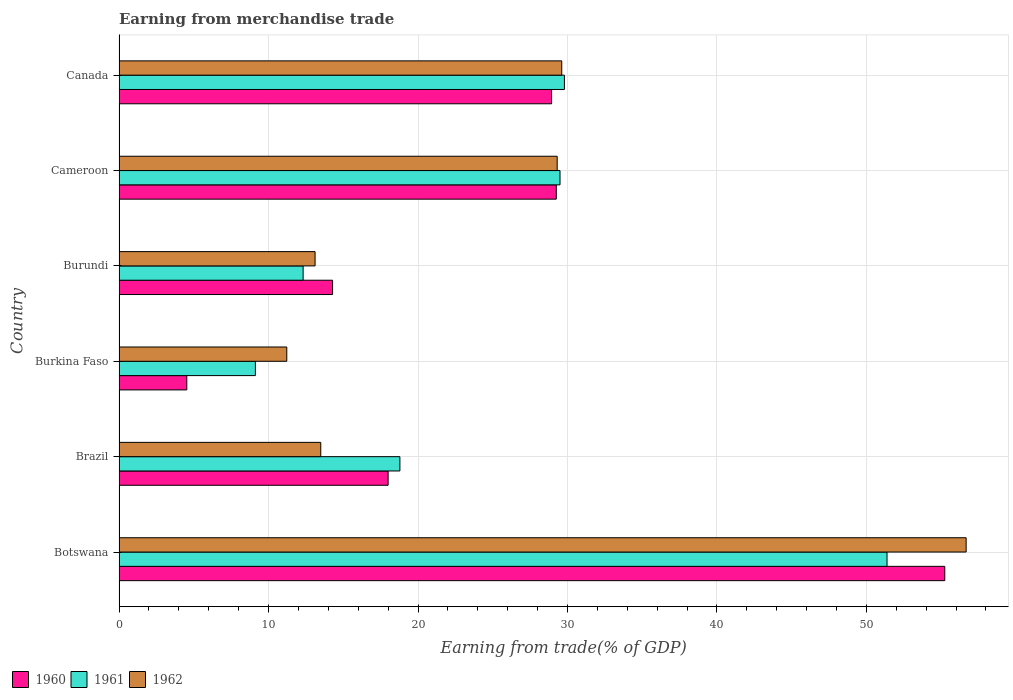What is the label of the 1st group of bars from the top?
Your answer should be very brief. Canada. What is the earnings from trade in 1960 in Canada?
Keep it short and to the point. 28.94. Across all countries, what is the maximum earnings from trade in 1960?
Offer a very short reply. 55.24. Across all countries, what is the minimum earnings from trade in 1960?
Your answer should be very brief. 4.53. In which country was the earnings from trade in 1960 maximum?
Your answer should be very brief. Botswana. In which country was the earnings from trade in 1962 minimum?
Keep it short and to the point. Burkina Faso. What is the total earnings from trade in 1960 in the graph?
Your answer should be very brief. 150.25. What is the difference between the earnings from trade in 1960 in Burundi and that in Canada?
Your answer should be compact. -14.65. What is the difference between the earnings from trade in 1962 in Burundi and the earnings from trade in 1960 in Brazil?
Provide a succinct answer. -4.89. What is the average earnings from trade in 1961 per country?
Provide a succinct answer. 25.15. What is the difference between the earnings from trade in 1961 and earnings from trade in 1960 in Burkina Faso?
Make the answer very short. 4.59. In how many countries, is the earnings from trade in 1962 greater than 40 %?
Your answer should be very brief. 1. What is the ratio of the earnings from trade in 1960 in Burundi to that in Cameroon?
Your response must be concise. 0.49. Is the earnings from trade in 1962 in Brazil less than that in Burkina Faso?
Make the answer very short. No. What is the difference between the highest and the second highest earnings from trade in 1961?
Your response must be concise. 21.58. What is the difference between the highest and the lowest earnings from trade in 1961?
Your answer should be very brief. 42.26. How many bars are there?
Ensure brevity in your answer.  18. Are all the bars in the graph horizontal?
Your response must be concise. Yes. What is the difference between two consecutive major ticks on the X-axis?
Provide a succinct answer. 10. Are the values on the major ticks of X-axis written in scientific E-notation?
Offer a terse response. No. What is the title of the graph?
Provide a short and direct response. Earning from merchandise trade. Does "1966" appear as one of the legend labels in the graph?
Make the answer very short. No. What is the label or title of the X-axis?
Keep it short and to the point. Earning from trade(% of GDP). What is the label or title of the Y-axis?
Offer a terse response. Country. What is the Earning from trade(% of GDP) of 1960 in Botswana?
Provide a succinct answer. 55.24. What is the Earning from trade(% of GDP) in 1961 in Botswana?
Provide a succinct answer. 51.38. What is the Earning from trade(% of GDP) in 1962 in Botswana?
Ensure brevity in your answer.  56.67. What is the Earning from trade(% of GDP) of 1960 in Brazil?
Your answer should be compact. 18. What is the Earning from trade(% of GDP) in 1961 in Brazil?
Offer a terse response. 18.79. What is the Earning from trade(% of GDP) in 1962 in Brazil?
Ensure brevity in your answer.  13.49. What is the Earning from trade(% of GDP) of 1960 in Burkina Faso?
Your response must be concise. 4.53. What is the Earning from trade(% of GDP) in 1961 in Burkina Faso?
Keep it short and to the point. 9.12. What is the Earning from trade(% of GDP) of 1962 in Burkina Faso?
Your response must be concise. 11.22. What is the Earning from trade(% of GDP) of 1960 in Burundi?
Make the answer very short. 14.29. What is the Earning from trade(% of GDP) of 1961 in Burundi?
Provide a short and direct response. 12.32. What is the Earning from trade(% of GDP) of 1962 in Burundi?
Offer a very short reply. 13.11. What is the Earning from trade(% of GDP) of 1960 in Cameroon?
Keep it short and to the point. 29.25. What is the Earning from trade(% of GDP) in 1961 in Cameroon?
Keep it short and to the point. 29.5. What is the Earning from trade(% of GDP) of 1962 in Cameroon?
Your answer should be compact. 29.31. What is the Earning from trade(% of GDP) of 1960 in Canada?
Provide a succinct answer. 28.94. What is the Earning from trade(% of GDP) of 1961 in Canada?
Give a very brief answer. 29.8. What is the Earning from trade(% of GDP) in 1962 in Canada?
Your answer should be compact. 29.62. Across all countries, what is the maximum Earning from trade(% of GDP) of 1960?
Offer a very short reply. 55.24. Across all countries, what is the maximum Earning from trade(% of GDP) of 1961?
Your answer should be very brief. 51.38. Across all countries, what is the maximum Earning from trade(% of GDP) in 1962?
Ensure brevity in your answer.  56.67. Across all countries, what is the minimum Earning from trade(% of GDP) of 1960?
Provide a short and direct response. 4.53. Across all countries, what is the minimum Earning from trade(% of GDP) of 1961?
Provide a succinct answer. 9.12. Across all countries, what is the minimum Earning from trade(% of GDP) of 1962?
Keep it short and to the point. 11.22. What is the total Earning from trade(% of GDP) of 1960 in the graph?
Provide a short and direct response. 150.25. What is the total Earning from trade(% of GDP) in 1961 in the graph?
Ensure brevity in your answer.  150.9. What is the total Earning from trade(% of GDP) of 1962 in the graph?
Offer a terse response. 153.43. What is the difference between the Earning from trade(% of GDP) in 1960 in Botswana and that in Brazil?
Provide a succinct answer. 37.24. What is the difference between the Earning from trade(% of GDP) of 1961 in Botswana and that in Brazil?
Keep it short and to the point. 32.59. What is the difference between the Earning from trade(% of GDP) of 1962 in Botswana and that in Brazil?
Ensure brevity in your answer.  43.18. What is the difference between the Earning from trade(% of GDP) in 1960 in Botswana and that in Burkina Faso?
Offer a terse response. 50.71. What is the difference between the Earning from trade(% of GDP) in 1961 in Botswana and that in Burkina Faso?
Make the answer very short. 42.26. What is the difference between the Earning from trade(% of GDP) of 1962 in Botswana and that in Burkina Faso?
Provide a short and direct response. 45.45. What is the difference between the Earning from trade(% of GDP) in 1960 in Botswana and that in Burundi?
Give a very brief answer. 40.96. What is the difference between the Earning from trade(% of GDP) of 1961 in Botswana and that in Burundi?
Your response must be concise. 39.06. What is the difference between the Earning from trade(% of GDP) of 1962 in Botswana and that in Burundi?
Offer a terse response. 43.56. What is the difference between the Earning from trade(% of GDP) of 1960 in Botswana and that in Cameroon?
Give a very brief answer. 25.99. What is the difference between the Earning from trade(% of GDP) in 1961 in Botswana and that in Cameroon?
Your answer should be very brief. 21.88. What is the difference between the Earning from trade(% of GDP) in 1962 in Botswana and that in Cameroon?
Your answer should be compact. 27.36. What is the difference between the Earning from trade(% of GDP) of 1960 in Botswana and that in Canada?
Provide a succinct answer. 26.3. What is the difference between the Earning from trade(% of GDP) of 1961 in Botswana and that in Canada?
Provide a succinct answer. 21.58. What is the difference between the Earning from trade(% of GDP) in 1962 in Botswana and that in Canada?
Keep it short and to the point. 27.05. What is the difference between the Earning from trade(% of GDP) in 1960 in Brazil and that in Burkina Faso?
Provide a short and direct response. 13.47. What is the difference between the Earning from trade(% of GDP) of 1961 in Brazil and that in Burkina Faso?
Your answer should be compact. 9.67. What is the difference between the Earning from trade(% of GDP) of 1962 in Brazil and that in Burkina Faso?
Keep it short and to the point. 2.27. What is the difference between the Earning from trade(% of GDP) of 1960 in Brazil and that in Burundi?
Keep it short and to the point. 3.72. What is the difference between the Earning from trade(% of GDP) in 1961 in Brazil and that in Burundi?
Offer a very short reply. 6.47. What is the difference between the Earning from trade(% of GDP) in 1962 in Brazil and that in Burundi?
Your answer should be very brief. 0.38. What is the difference between the Earning from trade(% of GDP) in 1960 in Brazil and that in Cameroon?
Ensure brevity in your answer.  -11.25. What is the difference between the Earning from trade(% of GDP) of 1961 in Brazil and that in Cameroon?
Make the answer very short. -10.71. What is the difference between the Earning from trade(% of GDP) in 1962 in Brazil and that in Cameroon?
Ensure brevity in your answer.  -15.82. What is the difference between the Earning from trade(% of GDP) of 1960 in Brazil and that in Canada?
Your answer should be compact. -10.94. What is the difference between the Earning from trade(% of GDP) in 1961 in Brazil and that in Canada?
Give a very brief answer. -11.01. What is the difference between the Earning from trade(% of GDP) in 1962 in Brazil and that in Canada?
Provide a short and direct response. -16.12. What is the difference between the Earning from trade(% of GDP) in 1960 in Burkina Faso and that in Burundi?
Offer a very short reply. -9.75. What is the difference between the Earning from trade(% of GDP) in 1961 in Burkina Faso and that in Burundi?
Your response must be concise. -3.19. What is the difference between the Earning from trade(% of GDP) of 1962 in Burkina Faso and that in Burundi?
Offer a terse response. -1.89. What is the difference between the Earning from trade(% of GDP) of 1960 in Burkina Faso and that in Cameroon?
Provide a succinct answer. -24.72. What is the difference between the Earning from trade(% of GDP) in 1961 in Burkina Faso and that in Cameroon?
Your answer should be compact. -20.38. What is the difference between the Earning from trade(% of GDP) of 1962 in Burkina Faso and that in Cameroon?
Provide a short and direct response. -18.09. What is the difference between the Earning from trade(% of GDP) in 1960 in Burkina Faso and that in Canada?
Offer a very short reply. -24.41. What is the difference between the Earning from trade(% of GDP) of 1961 in Burkina Faso and that in Canada?
Make the answer very short. -20.68. What is the difference between the Earning from trade(% of GDP) in 1962 in Burkina Faso and that in Canada?
Your response must be concise. -18.4. What is the difference between the Earning from trade(% of GDP) of 1960 in Burundi and that in Cameroon?
Provide a succinct answer. -14.97. What is the difference between the Earning from trade(% of GDP) in 1961 in Burundi and that in Cameroon?
Provide a succinct answer. -17.19. What is the difference between the Earning from trade(% of GDP) of 1962 in Burundi and that in Cameroon?
Your answer should be very brief. -16.2. What is the difference between the Earning from trade(% of GDP) in 1960 in Burundi and that in Canada?
Your response must be concise. -14.65. What is the difference between the Earning from trade(% of GDP) of 1961 in Burundi and that in Canada?
Provide a short and direct response. -17.48. What is the difference between the Earning from trade(% of GDP) of 1962 in Burundi and that in Canada?
Offer a terse response. -16.5. What is the difference between the Earning from trade(% of GDP) in 1960 in Cameroon and that in Canada?
Offer a terse response. 0.32. What is the difference between the Earning from trade(% of GDP) in 1961 in Cameroon and that in Canada?
Keep it short and to the point. -0.3. What is the difference between the Earning from trade(% of GDP) in 1962 in Cameroon and that in Canada?
Offer a terse response. -0.3. What is the difference between the Earning from trade(% of GDP) of 1960 in Botswana and the Earning from trade(% of GDP) of 1961 in Brazil?
Your response must be concise. 36.45. What is the difference between the Earning from trade(% of GDP) of 1960 in Botswana and the Earning from trade(% of GDP) of 1962 in Brazil?
Ensure brevity in your answer.  41.75. What is the difference between the Earning from trade(% of GDP) in 1961 in Botswana and the Earning from trade(% of GDP) in 1962 in Brazil?
Your answer should be very brief. 37.88. What is the difference between the Earning from trade(% of GDP) of 1960 in Botswana and the Earning from trade(% of GDP) of 1961 in Burkina Faso?
Ensure brevity in your answer.  46.12. What is the difference between the Earning from trade(% of GDP) in 1960 in Botswana and the Earning from trade(% of GDP) in 1962 in Burkina Faso?
Keep it short and to the point. 44.02. What is the difference between the Earning from trade(% of GDP) of 1961 in Botswana and the Earning from trade(% of GDP) of 1962 in Burkina Faso?
Provide a short and direct response. 40.16. What is the difference between the Earning from trade(% of GDP) of 1960 in Botswana and the Earning from trade(% of GDP) of 1961 in Burundi?
Offer a very short reply. 42.93. What is the difference between the Earning from trade(% of GDP) in 1960 in Botswana and the Earning from trade(% of GDP) in 1962 in Burundi?
Your response must be concise. 42.13. What is the difference between the Earning from trade(% of GDP) in 1961 in Botswana and the Earning from trade(% of GDP) in 1962 in Burundi?
Provide a succinct answer. 38.26. What is the difference between the Earning from trade(% of GDP) of 1960 in Botswana and the Earning from trade(% of GDP) of 1961 in Cameroon?
Give a very brief answer. 25.74. What is the difference between the Earning from trade(% of GDP) in 1960 in Botswana and the Earning from trade(% of GDP) in 1962 in Cameroon?
Your answer should be compact. 25.93. What is the difference between the Earning from trade(% of GDP) in 1961 in Botswana and the Earning from trade(% of GDP) in 1962 in Cameroon?
Provide a short and direct response. 22.07. What is the difference between the Earning from trade(% of GDP) of 1960 in Botswana and the Earning from trade(% of GDP) of 1961 in Canada?
Provide a succinct answer. 25.45. What is the difference between the Earning from trade(% of GDP) in 1960 in Botswana and the Earning from trade(% of GDP) in 1962 in Canada?
Ensure brevity in your answer.  25.63. What is the difference between the Earning from trade(% of GDP) of 1961 in Botswana and the Earning from trade(% of GDP) of 1962 in Canada?
Offer a very short reply. 21.76. What is the difference between the Earning from trade(% of GDP) of 1960 in Brazil and the Earning from trade(% of GDP) of 1961 in Burkina Faso?
Your answer should be compact. 8.88. What is the difference between the Earning from trade(% of GDP) in 1960 in Brazil and the Earning from trade(% of GDP) in 1962 in Burkina Faso?
Your answer should be compact. 6.78. What is the difference between the Earning from trade(% of GDP) in 1961 in Brazil and the Earning from trade(% of GDP) in 1962 in Burkina Faso?
Provide a succinct answer. 7.57. What is the difference between the Earning from trade(% of GDP) of 1960 in Brazil and the Earning from trade(% of GDP) of 1961 in Burundi?
Provide a short and direct response. 5.69. What is the difference between the Earning from trade(% of GDP) in 1960 in Brazil and the Earning from trade(% of GDP) in 1962 in Burundi?
Your answer should be very brief. 4.89. What is the difference between the Earning from trade(% of GDP) of 1961 in Brazil and the Earning from trade(% of GDP) of 1962 in Burundi?
Your answer should be very brief. 5.68. What is the difference between the Earning from trade(% of GDP) of 1960 in Brazil and the Earning from trade(% of GDP) of 1961 in Cameroon?
Your answer should be very brief. -11.5. What is the difference between the Earning from trade(% of GDP) in 1960 in Brazil and the Earning from trade(% of GDP) in 1962 in Cameroon?
Provide a short and direct response. -11.31. What is the difference between the Earning from trade(% of GDP) in 1961 in Brazil and the Earning from trade(% of GDP) in 1962 in Cameroon?
Offer a terse response. -10.52. What is the difference between the Earning from trade(% of GDP) of 1960 in Brazil and the Earning from trade(% of GDP) of 1961 in Canada?
Ensure brevity in your answer.  -11.8. What is the difference between the Earning from trade(% of GDP) of 1960 in Brazil and the Earning from trade(% of GDP) of 1962 in Canada?
Offer a terse response. -11.62. What is the difference between the Earning from trade(% of GDP) in 1961 in Brazil and the Earning from trade(% of GDP) in 1962 in Canada?
Offer a very short reply. -10.83. What is the difference between the Earning from trade(% of GDP) of 1960 in Burkina Faso and the Earning from trade(% of GDP) of 1961 in Burundi?
Offer a terse response. -7.78. What is the difference between the Earning from trade(% of GDP) in 1960 in Burkina Faso and the Earning from trade(% of GDP) in 1962 in Burundi?
Ensure brevity in your answer.  -8.58. What is the difference between the Earning from trade(% of GDP) of 1961 in Burkina Faso and the Earning from trade(% of GDP) of 1962 in Burundi?
Your answer should be compact. -3.99. What is the difference between the Earning from trade(% of GDP) of 1960 in Burkina Faso and the Earning from trade(% of GDP) of 1961 in Cameroon?
Offer a very short reply. -24.97. What is the difference between the Earning from trade(% of GDP) of 1960 in Burkina Faso and the Earning from trade(% of GDP) of 1962 in Cameroon?
Offer a very short reply. -24.78. What is the difference between the Earning from trade(% of GDP) in 1961 in Burkina Faso and the Earning from trade(% of GDP) in 1962 in Cameroon?
Provide a short and direct response. -20.19. What is the difference between the Earning from trade(% of GDP) in 1960 in Burkina Faso and the Earning from trade(% of GDP) in 1961 in Canada?
Make the answer very short. -25.26. What is the difference between the Earning from trade(% of GDP) in 1960 in Burkina Faso and the Earning from trade(% of GDP) in 1962 in Canada?
Offer a very short reply. -25.08. What is the difference between the Earning from trade(% of GDP) in 1961 in Burkina Faso and the Earning from trade(% of GDP) in 1962 in Canada?
Your answer should be very brief. -20.5. What is the difference between the Earning from trade(% of GDP) of 1960 in Burundi and the Earning from trade(% of GDP) of 1961 in Cameroon?
Offer a very short reply. -15.22. What is the difference between the Earning from trade(% of GDP) of 1960 in Burundi and the Earning from trade(% of GDP) of 1962 in Cameroon?
Provide a short and direct response. -15.03. What is the difference between the Earning from trade(% of GDP) of 1961 in Burundi and the Earning from trade(% of GDP) of 1962 in Cameroon?
Keep it short and to the point. -17. What is the difference between the Earning from trade(% of GDP) of 1960 in Burundi and the Earning from trade(% of GDP) of 1961 in Canada?
Keep it short and to the point. -15.51. What is the difference between the Earning from trade(% of GDP) in 1960 in Burundi and the Earning from trade(% of GDP) in 1962 in Canada?
Your response must be concise. -15.33. What is the difference between the Earning from trade(% of GDP) of 1961 in Burundi and the Earning from trade(% of GDP) of 1962 in Canada?
Your answer should be very brief. -17.3. What is the difference between the Earning from trade(% of GDP) of 1960 in Cameroon and the Earning from trade(% of GDP) of 1961 in Canada?
Offer a very short reply. -0.54. What is the difference between the Earning from trade(% of GDP) of 1960 in Cameroon and the Earning from trade(% of GDP) of 1962 in Canada?
Your response must be concise. -0.36. What is the difference between the Earning from trade(% of GDP) in 1961 in Cameroon and the Earning from trade(% of GDP) in 1962 in Canada?
Your answer should be compact. -0.12. What is the average Earning from trade(% of GDP) of 1960 per country?
Keep it short and to the point. 25.04. What is the average Earning from trade(% of GDP) of 1961 per country?
Your answer should be very brief. 25.15. What is the average Earning from trade(% of GDP) of 1962 per country?
Ensure brevity in your answer.  25.57. What is the difference between the Earning from trade(% of GDP) in 1960 and Earning from trade(% of GDP) in 1961 in Botswana?
Provide a succinct answer. 3.86. What is the difference between the Earning from trade(% of GDP) of 1960 and Earning from trade(% of GDP) of 1962 in Botswana?
Your response must be concise. -1.43. What is the difference between the Earning from trade(% of GDP) in 1961 and Earning from trade(% of GDP) in 1962 in Botswana?
Your answer should be compact. -5.29. What is the difference between the Earning from trade(% of GDP) of 1960 and Earning from trade(% of GDP) of 1961 in Brazil?
Your answer should be very brief. -0.79. What is the difference between the Earning from trade(% of GDP) of 1960 and Earning from trade(% of GDP) of 1962 in Brazil?
Your response must be concise. 4.51. What is the difference between the Earning from trade(% of GDP) in 1961 and Earning from trade(% of GDP) in 1962 in Brazil?
Make the answer very short. 5.3. What is the difference between the Earning from trade(% of GDP) of 1960 and Earning from trade(% of GDP) of 1961 in Burkina Faso?
Keep it short and to the point. -4.59. What is the difference between the Earning from trade(% of GDP) in 1960 and Earning from trade(% of GDP) in 1962 in Burkina Faso?
Your answer should be very brief. -6.69. What is the difference between the Earning from trade(% of GDP) of 1961 and Earning from trade(% of GDP) of 1962 in Burkina Faso?
Provide a short and direct response. -2.1. What is the difference between the Earning from trade(% of GDP) of 1960 and Earning from trade(% of GDP) of 1961 in Burundi?
Provide a succinct answer. 1.97. What is the difference between the Earning from trade(% of GDP) in 1960 and Earning from trade(% of GDP) in 1962 in Burundi?
Make the answer very short. 1.17. What is the difference between the Earning from trade(% of GDP) in 1961 and Earning from trade(% of GDP) in 1962 in Burundi?
Provide a succinct answer. -0.8. What is the difference between the Earning from trade(% of GDP) in 1960 and Earning from trade(% of GDP) in 1961 in Cameroon?
Provide a short and direct response. -0.25. What is the difference between the Earning from trade(% of GDP) in 1960 and Earning from trade(% of GDP) in 1962 in Cameroon?
Make the answer very short. -0.06. What is the difference between the Earning from trade(% of GDP) in 1961 and Earning from trade(% of GDP) in 1962 in Cameroon?
Offer a very short reply. 0.19. What is the difference between the Earning from trade(% of GDP) in 1960 and Earning from trade(% of GDP) in 1961 in Canada?
Ensure brevity in your answer.  -0.86. What is the difference between the Earning from trade(% of GDP) in 1960 and Earning from trade(% of GDP) in 1962 in Canada?
Your answer should be very brief. -0.68. What is the difference between the Earning from trade(% of GDP) of 1961 and Earning from trade(% of GDP) of 1962 in Canada?
Offer a terse response. 0.18. What is the ratio of the Earning from trade(% of GDP) in 1960 in Botswana to that in Brazil?
Provide a short and direct response. 3.07. What is the ratio of the Earning from trade(% of GDP) in 1961 in Botswana to that in Brazil?
Provide a succinct answer. 2.73. What is the ratio of the Earning from trade(% of GDP) of 1962 in Botswana to that in Brazil?
Offer a terse response. 4.2. What is the ratio of the Earning from trade(% of GDP) of 1960 in Botswana to that in Burkina Faso?
Make the answer very short. 12.19. What is the ratio of the Earning from trade(% of GDP) in 1961 in Botswana to that in Burkina Faso?
Make the answer very short. 5.63. What is the ratio of the Earning from trade(% of GDP) of 1962 in Botswana to that in Burkina Faso?
Give a very brief answer. 5.05. What is the ratio of the Earning from trade(% of GDP) of 1960 in Botswana to that in Burundi?
Give a very brief answer. 3.87. What is the ratio of the Earning from trade(% of GDP) in 1961 in Botswana to that in Burundi?
Keep it short and to the point. 4.17. What is the ratio of the Earning from trade(% of GDP) of 1962 in Botswana to that in Burundi?
Offer a very short reply. 4.32. What is the ratio of the Earning from trade(% of GDP) in 1960 in Botswana to that in Cameroon?
Your answer should be compact. 1.89. What is the ratio of the Earning from trade(% of GDP) in 1961 in Botswana to that in Cameroon?
Give a very brief answer. 1.74. What is the ratio of the Earning from trade(% of GDP) of 1962 in Botswana to that in Cameroon?
Your answer should be compact. 1.93. What is the ratio of the Earning from trade(% of GDP) in 1960 in Botswana to that in Canada?
Provide a short and direct response. 1.91. What is the ratio of the Earning from trade(% of GDP) of 1961 in Botswana to that in Canada?
Provide a succinct answer. 1.72. What is the ratio of the Earning from trade(% of GDP) in 1962 in Botswana to that in Canada?
Ensure brevity in your answer.  1.91. What is the ratio of the Earning from trade(% of GDP) of 1960 in Brazil to that in Burkina Faso?
Provide a short and direct response. 3.97. What is the ratio of the Earning from trade(% of GDP) of 1961 in Brazil to that in Burkina Faso?
Give a very brief answer. 2.06. What is the ratio of the Earning from trade(% of GDP) in 1962 in Brazil to that in Burkina Faso?
Your answer should be very brief. 1.2. What is the ratio of the Earning from trade(% of GDP) in 1960 in Brazil to that in Burundi?
Offer a very short reply. 1.26. What is the ratio of the Earning from trade(% of GDP) in 1961 in Brazil to that in Burundi?
Offer a very short reply. 1.53. What is the ratio of the Earning from trade(% of GDP) in 1960 in Brazil to that in Cameroon?
Your response must be concise. 0.62. What is the ratio of the Earning from trade(% of GDP) in 1961 in Brazil to that in Cameroon?
Keep it short and to the point. 0.64. What is the ratio of the Earning from trade(% of GDP) of 1962 in Brazil to that in Cameroon?
Make the answer very short. 0.46. What is the ratio of the Earning from trade(% of GDP) of 1960 in Brazil to that in Canada?
Your response must be concise. 0.62. What is the ratio of the Earning from trade(% of GDP) of 1961 in Brazil to that in Canada?
Your response must be concise. 0.63. What is the ratio of the Earning from trade(% of GDP) in 1962 in Brazil to that in Canada?
Make the answer very short. 0.46. What is the ratio of the Earning from trade(% of GDP) in 1960 in Burkina Faso to that in Burundi?
Your answer should be very brief. 0.32. What is the ratio of the Earning from trade(% of GDP) in 1961 in Burkina Faso to that in Burundi?
Provide a short and direct response. 0.74. What is the ratio of the Earning from trade(% of GDP) in 1962 in Burkina Faso to that in Burundi?
Provide a short and direct response. 0.86. What is the ratio of the Earning from trade(% of GDP) in 1960 in Burkina Faso to that in Cameroon?
Offer a very short reply. 0.15. What is the ratio of the Earning from trade(% of GDP) of 1961 in Burkina Faso to that in Cameroon?
Keep it short and to the point. 0.31. What is the ratio of the Earning from trade(% of GDP) in 1962 in Burkina Faso to that in Cameroon?
Keep it short and to the point. 0.38. What is the ratio of the Earning from trade(% of GDP) of 1960 in Burkina Faso to that in Canada?
Offer a very short reply. 0.16. What is the ratio of the Earning from trade(% of GDP) in 1961 in Burkina Faso to that in Canada?
Your answer should be compact. 0.31. What is the ratio of the Earning from trade(% of GDP) of 1962 in Burkina Faso to that in Canada?
Ensure brevity in your answer.  0.38. What is the ratio of the Earning from trade(% of GDP) of 1960 in Burundi to that in Cameroon?
Give a very brief answer. 0.49. What is the ratio of the Earning from trade(% of GDP) of 1961 in Burundi to that in Cameroon?
Your answer should be very brief. 0.42. What is the ratio of the Earning from trade(% of GDP) in 1962 in Burundi to that in Cameroon?
Give a very brief answer. 0.45. What is the ratio of the Earning from trade(% of GDP) in 1960 in Burundi to that in Canada?
Your response must be concise. 0.49. What is the ratio of the Earning from trade(% of GDP) in 1961 in Burundi to that in Canada?
Your response must be concise. 0.41. What is the ratio of the Earning from trade(% of GDP) of 1962 in Burundi to that in Canada?
Keep it short and to the point. 0.44. What is the ratio of the Earning from trade(% of GDP) in 1960 in Cameroon to that in Canada?
Your response must be concise. 1.01. What is the ratio of the Earning from trade(% of GDP) in 1961 in Cameroon to that in Canada?
Provide a short and direct response. 0.99. What is the difference between the highest and the second highest Earning from trade(% of GDP) of 1960?
Your response must be concise. 25.99. What is the difference between the highest and the second highest Earning from trade(% of GDP) in 1961?
Provide a short and direct response. 21.58. What is the difference between the highest and the second highest Earning from trade(% of GDP) in 1962?
Your answer should be compact. 27.05. What is the difference between the highest and the lowest Earning from trade(% of GDP) in 1960?
Your response must be concise. 50.71. What is the difference between the highest and the lowest Earning from trade(% of GDP) of 1961?
Ensure brevity in your answer.  42.26. What is the difference between the highest and the lowest Earning from trade(% of GDP) of 1962?
Offer a very short reply. 45.45. 